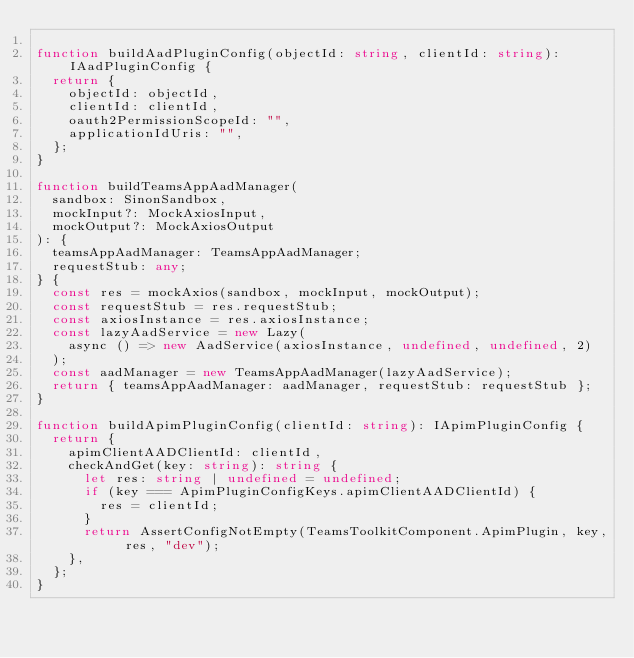<code> <loc_0><loc_0><loc_500><loc_500><_TypeScript_>
function buildAadPluginConfig(objectId: string, clientId: string): IAadPluginConfig {
  return {
    objectId: objectId,
    clientId: clientId,
    oauth2PermissionScopeId: "",
    applicationIdUris: "",
  };
}

function buildTeamsAppAadManager(
  sandbox: SinonSandbox,
  mockInput?: MockAxiosInput,
  mockOutput?: MockAxiosOutput
): {
  teamsAppAadManager: TeamsAppAadManager;
  requestStub: any;
} {
  const res = mockAxios(sandbox, mockInput, mockOutput);
  const requestStub = res.requestStub;
  const axiosInstance = res.axiosInstance;
  const lazyAadService = new Lazy(
    async () => new AadService(axiosInstance, undefined, undefined, 2)
  );
  const aadManager = new TeamsAppAadManager(lazyAadService);
  return { teamsAppAadManager: aadManager, requestStub: requestStub };
}

function buildApimPluginConfig(clientId: string): IApimPluginConfig {
  return {
    apimClientAADClientId: clientId,
    checkAndGet(key: string): string {
      let res: string | undefined = undefined;
      if (key === ApimPluginConfigKeys.apimClientAADClientId) {
        res = clientId;
      }
      return AssertConfigNotEmpty(TeamsToolkitComponent.ApimPlugin, key, res, "dev");
    },
  };
}
</code> 